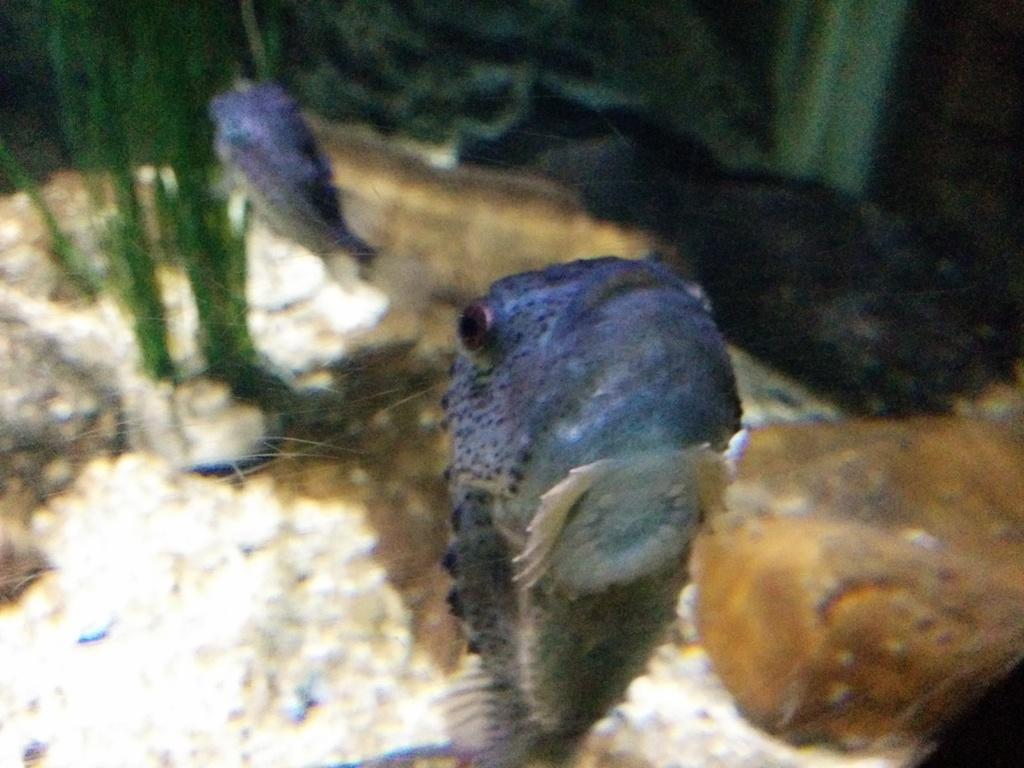What is the main subject of the picture? The main subject of the picture is an aquarium. What can be seen inside the aquarium? There are many fishes present in the aquarium. What type of texture can be seen on the tail of the stick in the image? There is no stick or tail present in the image; it features an aquarium with many fishes. 